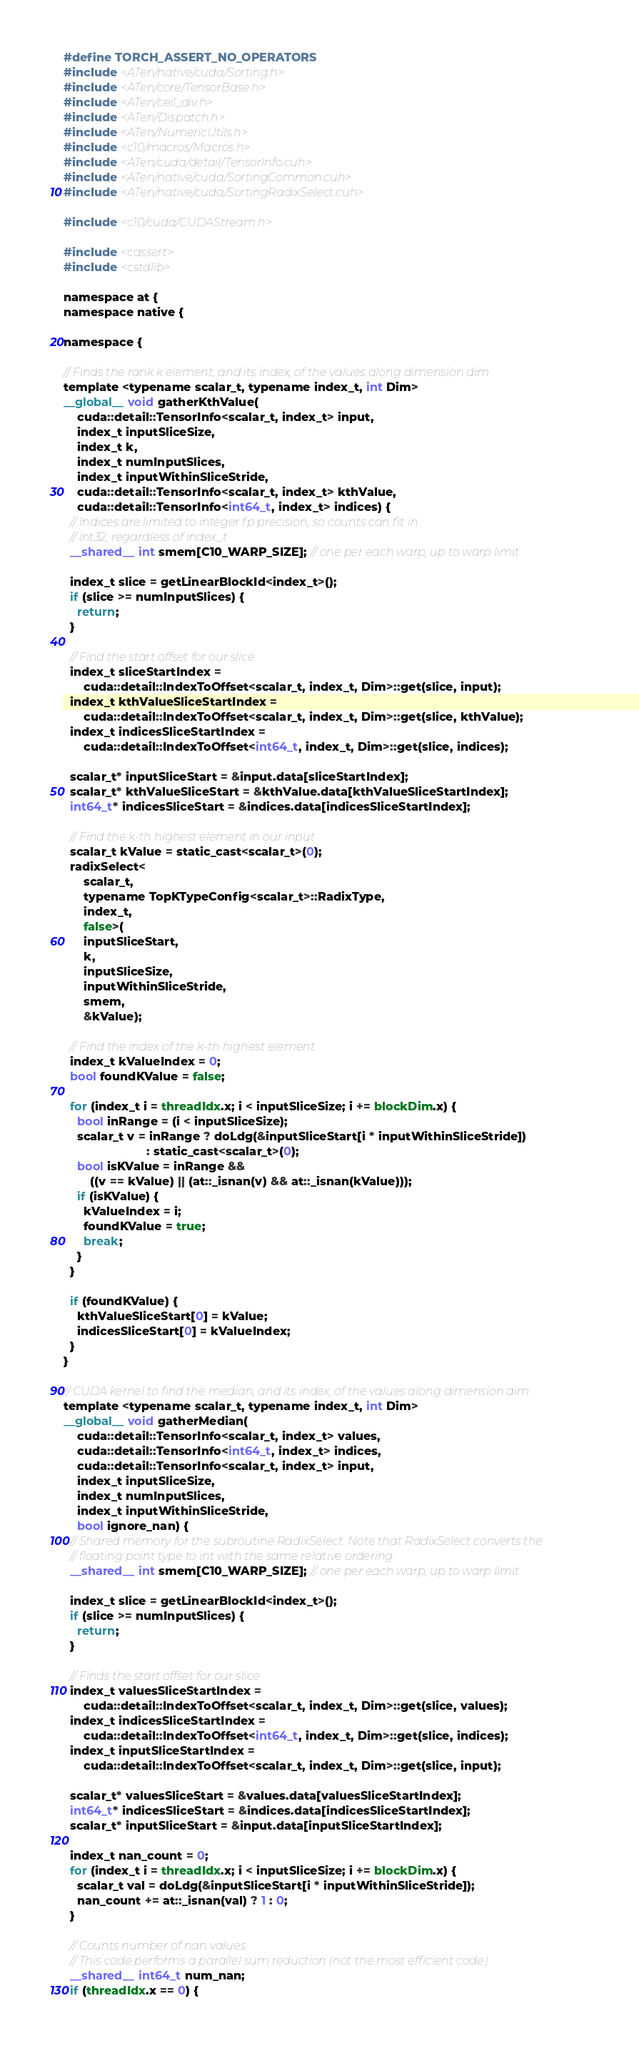Convert code to text. <code><loc_0><loc_0><loc_500><loc_500><_Cuda_>#define TORCH_ASSERT_NO_OPERATORS
#include <ATen/native/cuda/Sorting.h>
#include <ATen/core/TensorBase.h>
#include <ATen/ceil_div.h>
#include <ATen/Dispatch.h>
#include <ATen/NumericUtils.h>
#include <c10/macros/Macros.h>
#include <ATen/cuda/detail/TensorInfo.cuh>
#include <ATen/native/cuda/SortingCommon.cuh>
#include <ATen/native/cuda/SortingRadixSelect.cuh>

#include <c10/cuda/CUDAStream.h>

#include <cassert>
#include <cstdlib>

namespace at {
namespace native {

namespace {

// Finds the rank k element, and its index, of the values along dimension dim
template <typename scalar_t, typename index_t, int Dim>
__global__ void gatherKthValue(
    cuda::detail::TensorInfo<scalar_t, index_t> input,
    index_t inputSliceSize,
    index_t k,
    index_t numInputSlices,
    index_t inputWithinSliceStride,
    cuda::detail::TensorInfo<scalar_t, index_t> kthValue,
    cuda::detail::TensorInfo<int64_t, index_t> indices) {
  // Indices are limited to integer fp precision, so counts can fit in
  // int32, regardless of index_t
  __shared__ int smem[C10_WARP_SIZE]; // one per each warp, up to warp limit

  index_t slice = getLinearBlockId<index_t>();
  if (slice >= numInputSlices) {
    return;
  }

  // Find the start offset for our slice
  index_t sliceStartIndex =
      cuda::detail::IndexToOffset<scalar_t, index_t, Dim>::get(slice, input);
  index_t kthValueSliceStartIndex =
      cuda::detail::IndexToOffset<scalar_t, index_t, Dim>::get(slice, kthValue);
  index_t indicesSliceStartIndex =
      cuda::detail::IndexToOffset<int64_t, index_t, Dim>::get(slice, indices);

  scalar_t* inputSliceStart = &input.data[sliceStartIndex];
  scalar_t* kthValueSliceStart = &kthValue.data[kthValueSliceStartIndex];
  int64_t* indicesSliceStart = &indices.data[indicesSliceStartIndex];

  // Find the k-th highest element in our input
  scalar_t kValue = static_cast<scalar_t>(0);
  radixSelect<
      scalar_t,
      typename TopKTypeConfig<scalar_t>::RadixType,
      index_t,
      false>(
      inputSliceStart,
      k,
      inputSliceSize,
      inputWithinSliceStride,
      smem,
      &kValue);

  // Find the index of the k-th highest element
  index_t kValueIndex = 0;
  bool foundKValue = false;

  for (index_t i = threadIdx.x; i < inputSliceSize; i += blockDim.x) {
    bool inRange = (i < inputSliceSize);
    scalar_t v = inRange ? doLdg(&inputSliceStart[i * inputWithinSliceStride])
                         : static_cast<scalar_t>(0);
    bool isKValue = inRange &&
        ((v == kValue) || (at::_isnan(v) && at::_isnan(kValue)));
    if (isKValue) {
      kValueIndex = i;
      foundKValue = true;
      break;
    }
  }

  if (foundKValue) {
    kthValueSliceStart[0] = kValue;
    indicesSliceStart[0] = kValueIndex;
  }
}

// CUDA kernel to find the median, and its index, of the values along dimension dim
template <typename scalar_t, typename index_t, int Dim>
__global__ void gatherMedian(
    cuda::detail::TensorInfo<scalar_t, index_t> values,
    cuda::detail::TensorInfo<int64_t, index_t> indices,
    cuda::detail::TensorInfo<scalar_t, index_t> input,
    index_t inputSliceSize,
    index_t numInputSlices,
    index_t inputWithinSliceStride,
    bool ignore_nan) {
  // Shared memory for the subroutine RadixSelect. Note that RadixSelect converts the
  // floating point type to int with the same relative ordering.
  __shared__ int smem[C10_WARP_SIZE]; // one per each warp, up to warp limit

  index_t slice = getLinearBlockId<index_t>();
  if (slice >= numInputSlices) {
    return;
  }

  // Finds the start offset for our slice
  index_t valuesSliceStartIndex =
      cuda::detail::IndexToOffset<scalar_t, index_t, Dim>::get(slice, values);
  index_t indicesSliceStartIndex =
      cuda::detail::IndexToOffset<int64_t, index_t, Dim>::get(slice, indices);
  index_t inputSliceStartIndex =
      cuda::detail::IndexToOffset<scalar_t, index_t, Dim>::get(slice, input);

  scalar_t* valuesSliceStart = &values.data[valuesSliceStartIndex];
  int64_t* indicesSliceStart = &indices.data[indicesSliceStartIndex];
  scalar_t* inputSliceStart = &input.data[inputSliceStartIndex];

  index_t nan_count = 0;
  for (index_t i = threadIdx.x; i < inputSliceSize; i += blockDim.x) {
    scalar_t val = doLdg(&inputSliceStart[i * inputWithinSliceStride]);
    nan_count += at::_isnan(val) ? 1 : 0;
  }

  // Counts number of nan values
  // This code performs a parallel sum reduction (not the most efficient code)
  __shared__ int64_t num_nan;
  if (threadIdx.x == 0) {</code> 